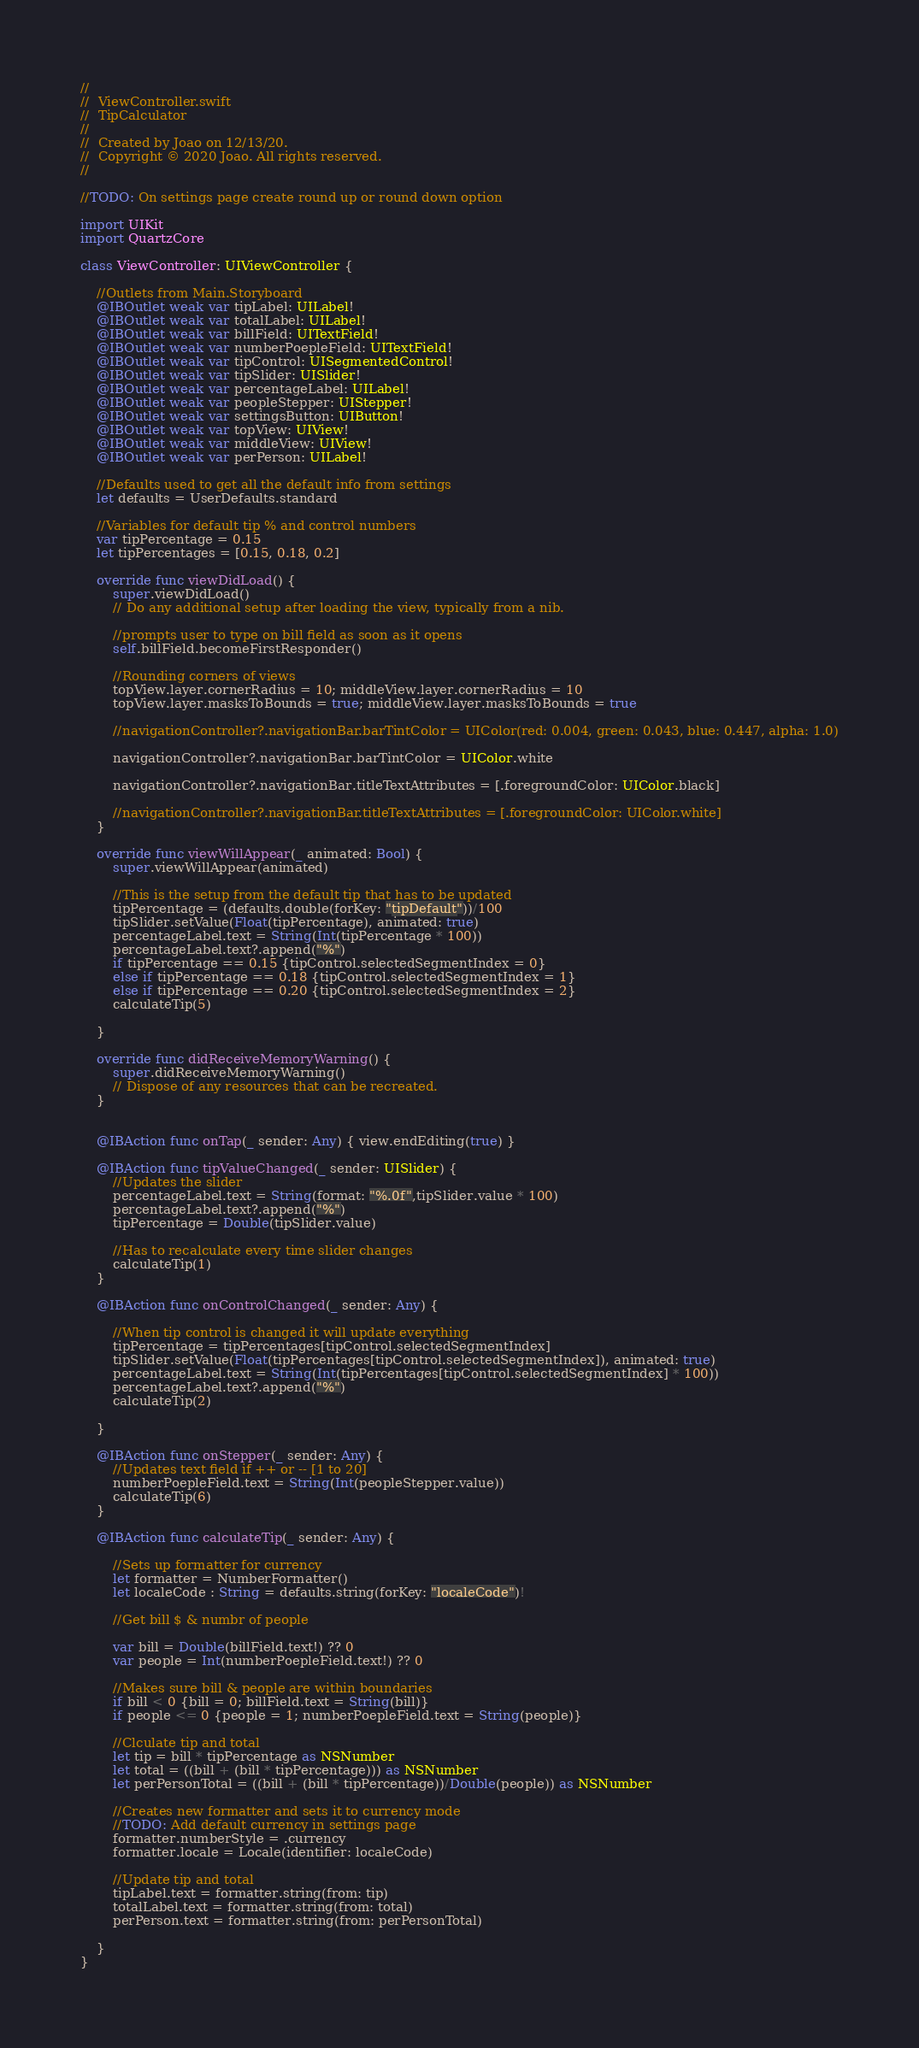Convert code to text. <code><loc_0><loc_0><loc_500><loc_500><_Swift_>//
//  ViewController.swift
//  TipCalculator
//
//  Created by Joao on 12/13/20.
//  Copyright © 2020 Joao. All rights reserved.
//

//TODO: On settings page create round up or round down option

import UIKit
import QuartzCore

class ViewController: UIViewController {

    //Outlets from Main.Storyboard
    @IBOutlet weak var tipLabel: UILabel!
    @IBOutlet weak var totalLabel: UILabel!
    @IBOutlet weak var billField: UITextField!
    @IBOutlet weak var numberPoepleField: UITextField!
    @IBOutlet weak var tipControl: UISegmentedControl!
    @IBOutlet weak var tipSlider: UISlider!
    @IBOutlet weak var percentageLabel: UILabel!
    @IBOutlet weak var peopleStepper: UIStepper!
    @IBOutlet weak var settingsButton: UIButton!
    @IBOutlet weak var topView: UIView!
    @IBOutlet weak var middleView: UIView!
    @IBOutlet weak var perPerson: UILabel!
    
    //Defaults used to get all the default info from settings
    let defaults = UserDefaults.standard
    
    //Variables for default tip % and control numbers
    var tipPercentage = 0.15
    let tipPercentages = [0.15, 0.18, 0.2]
    
    override func viewDidLoad() {
        super.viewDidLoad()
        // Do any additional setup after loading the view, typically from a nib.
        
        //prompts user to type on bill field as soon as it opens
        self.billField.becomeFirstResponder()
        
        //Rounding corners of views
        topView.layer.cornerRadius = 10; middleView.layer.cornerRadius = 10
        topView.layer.masksToBounds = true; middleView.layer.masksToBounds = true
        
        //navigationController?.navigationBar.barTintColor = UIColor(red: 0.004, green: 0.043, blue: 0.447, alpha: 1.0)
        
        navigationController?.navigationBar.barTintColor = UIColor.white
        
        navigationController?.navigationBar.titleTextAttributes = [.foregroundColor: UIColor.black]
    
        //navigationController?.navigationBar.titleTextAttributes = [.foregroundColor: UIColor.white]
    }
    
    override func viewWillAppear(_ animated: Bool) {
        super.viewWillAppear(animated)

        //This is the setup from the default tip that has to be updated
        tipPercentage = (defaults.double(forKey: "tipDefault"))/100
        tipSlider.setValue(Float(tipPercentage), animated: true)
        percentageLabel.text = String(Int(tipPercentage * 100))
        percentageLabel.text?.append("%")
        if tipPercentage == 0.15 {tipControl.selectedSegmentIndex = 0}
        else if tipPercentage == 0.18 {tipControl.selectedSegmentIndex = 1}
        else if tipPercentage == 0.20 {tipControl.selectedSegmentIndex = 2}
        calculateTip(5)
        
    }

    override func didReceiveMemoryWarning() {
        super.didReceiveMemoryWarning()
        // Dispose of any resources that can be recreated.
    }

    
    @IBAction func onTap(_ sender: Any) { view.endEditing(true) }
    
    @IBAction func tipValueChanged(_ sender: UISlider) {
        //Updates the slider
        percentageLabel.text = String(format: "%.0f",tipSlider.value * 100)
        percentageLabel.text?.append("%")
        tipPercentage = Double(tipSlider.value)
        
        //Has to recalculate every time slider changes
        calculateTip(1)
    }
    
    @IBAction func onControlChanged(_ sender: Any) {
        
        //When tip control is changed it will update everything
        tipPercentage = tipPercentages[tipControl.selectedSegmentIndex]
        tipSlider.setValue(Float(tipPercentages[tipControl.selectedSegmentIndex]), animated: true)
        percentageLabel.text = String(Int(tipPercentages[tipControl.selectedSegmentIndex] * 100))
        percentageLabel.text?.append("%")
        calculateTip(2)
        
    }
    
    @IBAction func onStepper(_ sender: Any) {
        //Updates text field if ++ or -- [1 to 20]
        numberPoepleField.text = String(Int(peopleStepper.value))
        calculateTip(6)
    }
    
    @IBAction func calculateTip(_ sender: Any) {
        
        //Sets up formatter for currency
        let formatter = NumberFormatter()
        let localeCode : String = defaults.string(forKey: "localeCode")!
        
        //Get bill $ & numbr of people
        
        var bill = Double(billField.text!) ?? 0
        var people = Int(numberPoepleField.text!) ?? 0
        
        //Makes sure bill & people are within boundaries
        if bill < 0 {bill = 0; billField.text = String(bill)}
        if people <= 0 {people = 1; numberPoepleField.text = String(people)}
        
        //Clculate tip and total
        let tip = bill * tipPercentage as NSNumber
        let total = ((bill + (bill * tipPercentage))) as NSNumber
        let perPersonTotal = ((bill + (bill * tipPercentage))/Double(people)) as NSNumber
        
        //Creates new formatter and sets it to currency mode
        //TODO: Add default currency in settings page
        formatter.numberStyle = .currency
        formatter.locale = Locale(identifier: localeCode)
        
        //Update tip and total
        tipLabel.text = formatter.string(from: tip)
        totalLabel.text = formatter.string(from: total)
        perPerson.text = formatter.string(from: perPersonTotal)
        
    }
}

</code> 